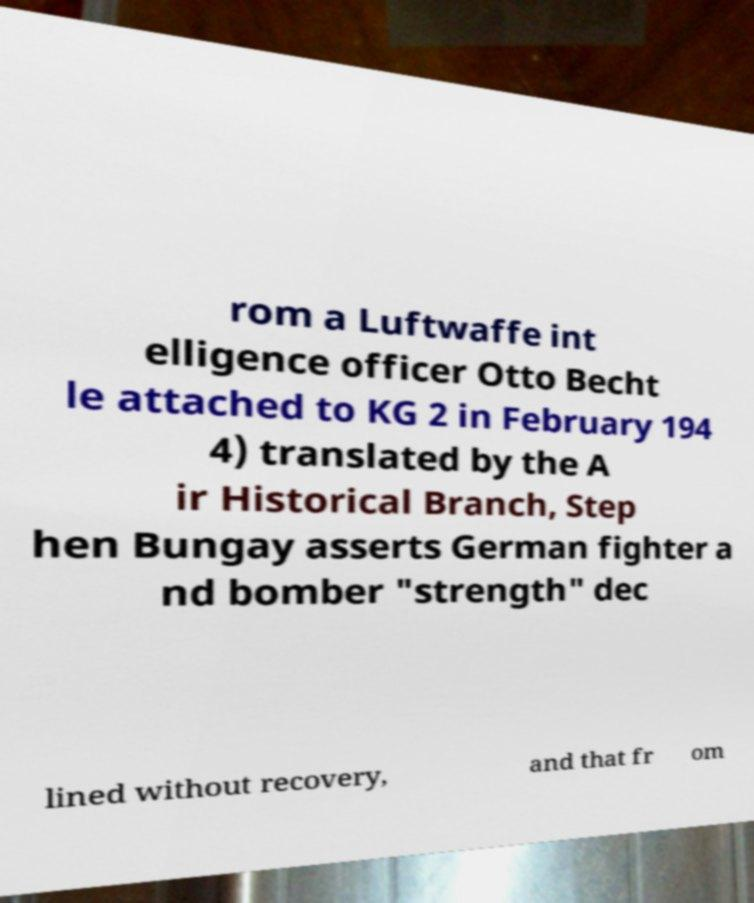There's text embedded in this image that I need extracted. Can you transcribe it verbatim? rom a Luftwaffe int elligence officer Otto Becht le attached to KG 2 in February 194 4) translated by the A ir Historical Branch, Step hen Bungay asserts German fighter a nd bomber "strength" dec lined without recovery, and that fr om 